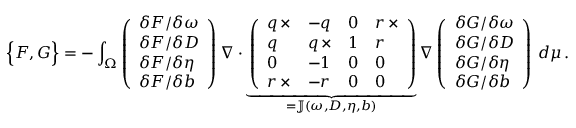<formula> <loc_0><loc_0><loc_500><loc_500>\left \{ F , G \right \} = - \int _ { \Omega } \left ( \begin{array} { l } { \delta F / \delta \omega } \\ { \delta F / \delta D } \\ { \delta F / \delta \eta } \\ { \delta F / \delta b } \end{array} \right ) \nabla \cdot \underbrace { \left ( \begin{array} { l l l l } { q \, \times } & { - q } & { 0 } & { r \, \times } \\ { q } & { q \, \times } & { 1 } & { r } \\ { 0 } & { - 1 } & { 0 } & { 0 } \\ { r \, \times } & { - r } & { 0 } & { 0 } \end{array} \right ) } _ { = \mathbb { J } ( \omega , D , \eta , b ) } \nabla \left ( \begin{array} { l } { \delta G / \delta \omega } \\ { \delta G / \delta D } \\ { \delta G / \delta \eta } \\ { \delta G / \delta b } \end{array} \right ) \, d \mu \, .</formula> 